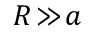Convert formula to latex. <formula><loc_0><loc_0><loc_500><loc_500>R \, \gg \, a</formula> 